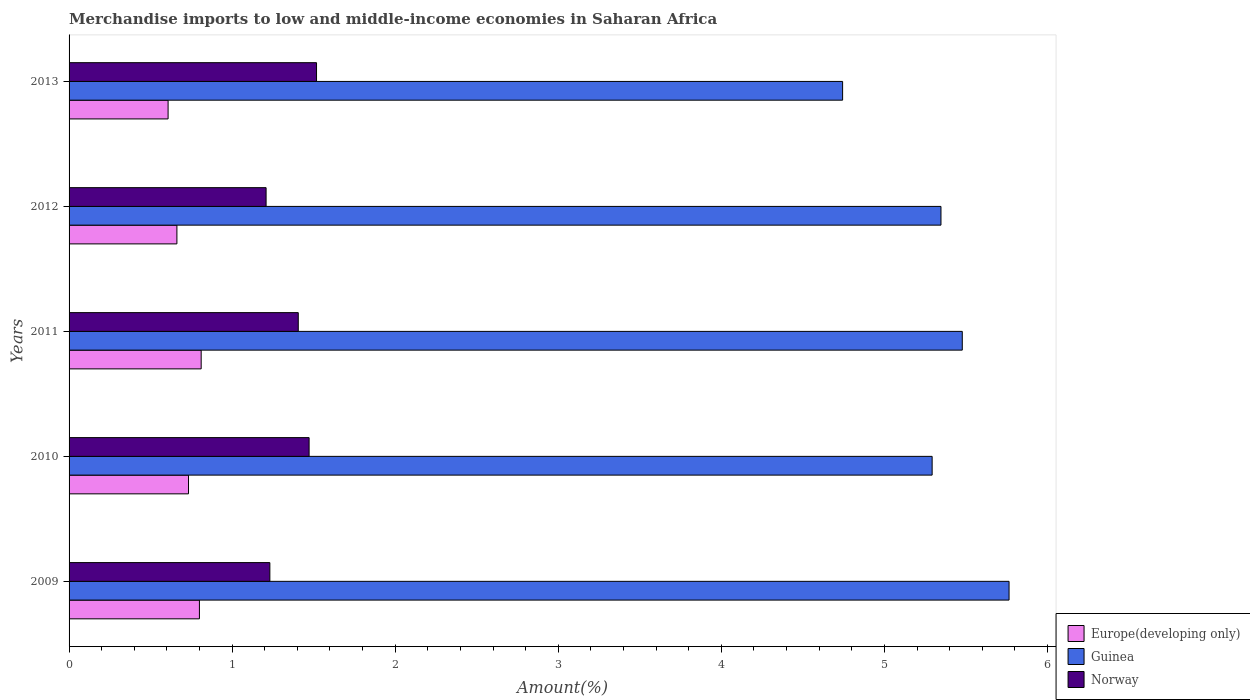How many different coloured bars are there?
Your answer should be compact. 3. Are the number of bars on each tick of the Y-axis equal?
Your response must be concise. Yes. How many bars are there on the 5th tick from the top?
Make the answer very short. 3. How many bars are there on the 2nd tick from the bottom?
Make the answer very short. 3. What is the percentage of amount earned from merchandise imports in Europe(developing only) in 2011?
Ensure brevity in your answer.  0.81. Across all years, what is the maximum percentage of amount earned from merchandise imports in Guinea?
Your answer should be very brief. 5.76. Across all years, what is the minimum percentage of amount earned from merchandise imports in Norway?
Keep it short and to the point. 1.21. In which year was the percentage of amount earned from merchandise imports in Guinea minimum?
Ensure brevity in your answer.  2013. What is the total percentage of amount earned from merchandise imports in Norway in the graph?
Offer a very short reply. 6.83. What is the difference between the percentage of amount earned from merchandise imports in Norway in 2011 and that in 2012?
Your response must be concise. 0.2. What is the difference between the percentage of amount earned from merchandise imports in Guinea in 2010 and the percentage of amount earned from merchandise imports in Europe(developing only) in 2013?
Your response must be concise. 4.69. What is the average percentage of amount earned from merchandise imports in Guinea per year?
Your response must be concise. 5.33. In the year 2011, what is the difference between the percentage of amount earned from merchandise imports in Guinea and percentage of amount earned from merchandise imports in Norway?
Provide a short and direct response. 4.07. What is the ratio of the percentage of amount earned from merchandise imports in Europe(developing only) in 2009 to that in 2011?
Give a very brief answer. 0.99. Is the percentage of amount earned from merchandise imports in Norway in 2010 less than that in 2013?
Provide a succinct answer. Yes. Is the difference between the percentage of amount earned from merchandise imports in Guinea in 2012 and 2013 greater than the difference between the percentage of amount earned from merchandise imports in Norway in 2012 and 2013?
Your answer should be very brief. Yes. What is the difference between the highest and the second highest percentage of amount earned from merchandise imports in Norway?
Give a very brief answer. 0.05. What is the difference between the highest and the lowest percentage of amount earned from merchandise imports in Europe(developing only)?
Keep it short and to the point. 0.2. What does the 2nd bar from the bottom in 2012 represents?
Give a very brief answer. Guinea. Are all the bars in the graph horizontal?
Your answer should be very brief. Yes. Are the values on the major ticks of X-axis written in scientific E-notation?
Your answer should be compact. No. Does the graph contain grids?
Your answer should be very brief. No. How many legend labels are there?
Your answer should be compact. 3. What is the title of the graph?
Provide a short and direct response. Merchandise imports to low and middle-income economies in Saharan Africa. What is the label or title of the X-axis?
Give a very brief answer. Amount(%). What is the Amount(%) in Europe(developing only) in 2009?
Ensure brevity in your answer.  0.8. What is the Amount(%) of Guinea in 2009?
Make the answer very short. 5.76. What is the Amount(%) of Norway in 2009?
Ensure brevity in your answer.  1.23. What is the Amount(%) in Europe(developing only) in 2010?
Make the answer very short. 0.73. What is the Amount(%) of Guinea in 2010?
Your answer should be compact. 5.29. What is the Amount(%) of Norway in 2010?
Make the answer very short. 1.47. What is the Amount(%) in Europe(developing only) in 2011?
Make the answer very short. 0.81. What is the Amount(%) of Guinea in 2011?
Provide a succinct answer. 5.48. What is the Amount(%) of Norway in 2011?
Provide a short and direct response. 1.41. What is the Amount(%) of Europe(developing only) in 2012?
Your answer should be very brief. 0.66. What is the Amount(%) in Guinea in 2012?
Offer a very short reply. 5.35. What is the Amount(%) of Norway in 2012?
Your answer should be compact. 1.21. What is the Amount(%) in Europe(developing only) in 2013?
Provide a short and direct response. 0.61. What is the Amount(%) in Guinea in 2013?
Provide a succinct answer. 4.74. What is the Amount(%) in Norway in 2013?
Provide a short and direct response. 1.52. Across all years, what is the maximum Amount(%) of Europe(developing only)?
Your response must be concise. 0.81. Across all years, what is the maximum Amount(%) in Guinea?
Your response must be concise. 5.76. Across all years, what is the maximum Amount(%) of Norway?
Provide a short and direct response. 1.52. Across all years, what is the minimum Amount(%) of Europe(developing only)?
Make the answer very short. 0.61. Across all years, what is the minimum Amount(%) of Guinea?
Ensure brevity in your answer.  4.74. Across all years, what is the minimum Amount(%) in Norway?
Keep it short and to the point. 1.21. What is the total Amount(%) of Europe(developing only) in the graph?
Offer a very short reply. 3.61. What is the total Amount(%) of Guinea in the graph?
Your answer should be compact. 26.63. What is the total Amount(%) in Norway in the graph?
Offer a very short reply. 6.83. What is the difference between the Amount(%) in Europe(developing only) in 2009 and that in 2010?
Offer a terse response. 0.07. What is the difference between the Amount(%) of Guinea in 2009 and that in 2010?
Provide a short and direct response. 0.47. What is the difference between the Amount(%) in Norway in 2009 and that in 2010?
Your response must be concise. -0.24. What is the difference between the Amount(%) of Europe(developing only) in 2009 and that in 2011?
Provide a short and direct response. -0.01. What is the difference between the Amount(%) in Guinea in 2009 and that in 2011?
Provide a succinct answer. 0.29. What is the difference between the Amount(%) of Norway in 2009 and that in 2011?
Provide a short and direct response. -0.17. What is the difference between the Amount(%) in Europe(developing only) in 2009 and that in 2012?
Your response must be concise. 0.14. What is the difference between the Amount(%) of Guinea in 2009 and that in 2012?
Offer a terse response. 0.42. What is the difference between the Amount(%) in Norway in 2009 and that in 2012?
Your response must be concise. 0.02. What is the difference between the Amount(%) of Europe(developing only) in 2009 and that in 2013?
Offer a terse response. 0.19. What is the difference between the Amount(%) of Guinea in 2009 and that in 2013?
Ensure brevity in your answer.  1.02. What is the difference between the Amount(%) in Norway in 2009 and that in 2013?
Your answer should be compact. -0.29. What is the difference between the Amount(%) in Europe(developing only) in 2010 and that in 2011?
Offer a terse response. -0.08. What is the difference between the Amount(%) in Guinea in 2010 and that in 2011?
Keep it short and to the point. -0.18. What is the difference between the Amount(%) of Norway in 2010 and that in 2011?
Your answer should be very brief. 0.07. What is the difference between the Amount(%) in Europe(developing only) in 2010 and that in 2012?
Your response must be concise. 0.07. What is the difference between the Amount(%) of Guinea in 2010 and that in 2012?
Make the answer very short. -0.05. What is the difference between the Amount(%) of Norway in 2010 and that in 2012?
Provide a succinct answer. 0.26. What is the difference between the Amount(%) of Europe(developing only) in 2010 and that in 2013?
Offer a terse response. 0.13. What is the difference between the Amount(%) in Guinea in 2010 and that in 2013?
Provide a succinct answer. 0.55. What is the difference between the Amount(%) of Norway in 2010 and that in 2013?
Offer a very short reply. -0.05. What is the difference between the Amount(%) of Europe(developing only) in 2011 and that in 2012?
Provide a short and direct response. 0.15. What is the difference between the Amount(%) of Guinea in 2011 and that in 2012?
Your answer should be very brief. 0.13. What is the difference between the Amount(%) in Norway in 2011 and that in 2012?
Ensure brevity in your answer.  0.2. What is the difference between the Amount(%) of Europe(developing only) in 2011 and that in 2013?
Provide a succinct answer. 0.2. What is the difference between the Amount(%) in Guinea in 2011 and that in 2013?
Provide a short and direct response. 0.73. What is the difference between the Amount(%) of Norway in 2011 and that in 2013?
Your answer should be compact. -0.11. What is the difference between the Amount(%) of Europe(developing only) in 2012 and that in 2013?
Ensure brevity in your answer.  0.05. What is the difference between the Amount(%) in Guinea in 2012 and that in 2013?
Offer a terse response. 0.6. What is the difference between the Amount(%) of Norway in 2012 and that in 2013?
Your answer should be compact. -0.31. What is the difference between the Amount(%) in Europe(developing only) in 2009 and the Amount(%) in Guinea in 2010?
Offer a very short reply. -4.49. What is the difference between the Amount(%) in Europe(developing only) in 2009 and the Amount(%) in Norway in 2010?
Provide a short and direct response. -0.67. What is the difference between the Amount(%) in Guinea in 2009 and the Amount(%) in Norway in 2010?
Keep it short and to the point. 4.29. What is the difference between the Amount(%) in Europe(developing only) in 2009 and the Amount(%) in Guinea in 2011?
Keep it short and to the point. -4.68. What is the difference between the Amount(%) of Europe(developing only) in 2009 and the Amount(%) of Norway in 2011?
Keep it short and to the point. -0.61. What is the difference between the Amount(%) in Guinea in 2009 and the Amount(%) in Norway in 2011?
Your answer should be very brief. 4.36. What is the difference between the Amount(%) in Europe(developing only) in 2009 and the Amount(%) in Guinea in 2012?
Keep it short and to the point. -4.55. What is the difference between the Amount(%) in Europe(developing only) in 2009 and the Amount(%) in Norway in 2012?
Provide a succinct answer. -0.41. What is the difference between the Amount(%) in Guinea in 2009 and the Amount(%) in Norway in 2012?
Make the answer very short. 4.56. What is the difference between the Amount(%) in Europe(developing only) in 2009 and the Amount(%) in Guinea in 2013?
Your answer should be very brief. -3.94. What is the difference between the Amount(%) in Europe(developing only) in 2009 and the Amount(%) in Norway in 2013?
Provide a succinct answer. -0.72. What is the difference between the Amount(%) of Guinea in 2009 and the Amount(%) of Norway in 2013?
Ensure brevity in your answer.  4.25. What is the difference between the Amount(%) in Europe(developing only) in 2010 and the Amount(%) in Guinea in 2011?
Your answer should be compact. -4.75. What is the difference between the Amount(%) in Europe(developing only) in 2010 and the Amount(%) in Norway in 2011?
Your response must be concise. -0.67. What is the difference between the Amount(%) of Guinea in 2010 and the Amount(%) of Norway in 2011?
Give a very brief answer. 3.89. What is the difference between the Amount(%) in Europe(developing only) in 2010 and the Amount(%) in Guinea in 2012?
Your response must be concise. -4.61. What is the difference between the Amount(%) in Europe(developing only) in 2010 and the Amount(%) in Norway in 2012?
Offer a terse response. -0.48. What is the difference between the Amount(%) in Guinea in 2010 and the Amount(%) in Norway in 2012?
Give a very brief answer. 4.08. What is the difference between the Amount(%) of Europe(developing only) in 2010 and the Amount(%) of Guinea in 2013?
Offer a terse response. -4.01. What is the difference between the Amount(%) of Europe(developing only) in 2010 and the Amount(%) of Norway in 2013?
Offer a terse response. -0.79. What is the difference between the Amount(%) of Guinea in 2010 and the Amount(%) of Norway in 2013?
Ensure brevity in your answer.  3.78. What is the difference between the Amount(%) in Europe(developing only) in 2011 and the Amount(%) in Guinea in 2012?
Provide a succinct answer. -4.54. What is the difference between the Amount(%) of Europe(developing only) in 2011 and the Amount(%) of Norway in 2012?
Your response must be concise. -0.4. What is the difference between the Amount(%) in Guinea in 2011 and the Amount(%) in Norway in 2012?
Keep it short and to the point. 4.27. What is the difference between the Amount(%) in Europe(developing only) in 2011 and the Amount(%) in Guinea in 2013?
Provide a short and direct response. -3.93. What is the difference between the Amount(%) of Europe(developing only) in 2011 and the Amount(%) of Norway in 2013?
Offer a very short reply. -0.71. What is the difference between the Amount(%) in Guinea in 2011 and the Amount(%) in Norway in 2013?
Keep it short and to the point. 3.96. What is the difference between the Amount(%) in Europe(developing only) in 2012 and the Amount(%) in Guinea in 2013?
Ensure brevity in your answer.  -4.08. What is the difference between the Amount(%) of Europe(developing only) in 2012 and the Amount(%) of Norway in 2013?
Offer a terse response. -0.86. What is the difference between the Amount(%) in Guinea in 2012 and the Amount(%) in Norway in 2013?
Your answer should be very brief. 3.83. What is the average Amount(%) of Europe(developing only) per year?
Offer a very short reply. 0.72. What is the average Amount(%) in Guinea per year?
Your response must be concise. 5.33. What is the average Amount(%) in Norway per year?
Give a very brief answer. 1.37. In the year 2009, what is the difference between the Amount(%) of Europe(developing only) and Amount(%) of Guinea?
Provide a succinct answer. -4.97. In the year 2009, what is the difference between the Amount(%) of Europe(developing only) and Amount(%) of Norway?
Your response must be concise. -0.43. In the year 2009, what is the difference between the Amount(%) in Guinea and Amount(%) in Norway?
Keep it short and to the point. 4.53. In the year 2010, what is the difference between the Amount(%) in Europe(developing only) and Amount(%) in Guinea?
Provide a succinct answer. -4.56. In the year 2010, what is the difference between the Amount(%) in Europe(developing only) and Amount(%) in Norway?
Give a very brief answer. -0.74. In the year 2010, what is the difference between the Amount(%) of Guinea and Amount(%) of Norway?
Provide a succinct answer. 3.82. In the year 2011, what is the difference between the Amount(%) of Europe(developing only) and Amount(%) of Guinea?
Offer a terse response. -4.67. In the year 2011, what is the difference between the Amount(%) in Europe(developing only) and Amount(%) in Norway?
Your response must be concise. -0.6. In the year 2011, what is the difference between the Amount(%) of Guinea and Amount(%) of Norway?
Your answer should be compact. 4.07. In the year 2012, what is the difference between the Amount(%) in Europe(developing only) and Amount(%) in Guinea?
Your answer should be very brief. -4.69. In the year 2012, what is the difference between the Amount(%) in Europe(developing only) and Amount(%) in Norway?
Offer a very short reply. -0.55. In the year 2012, what is the difference between the Amount(%) in Guinea and Amount(%) in Norway?
Provide a short and direct response. 4.14. In the year 2013, what is the difference between the Amount(%) in Europe(developing only) and Amount(%) in Guinea?
Your answer should be very brief. -4.14. In the year 2013, what is the difference between the Amount(%) of Europe(developing only) and Amount(%) of Norway?
Your answer should be very brief. -0.91. In the year 2013, what is the difference between the Amount(%) of Guinea and Amount(%) of Norway?
Provide a short and direct response. 3.23. What is the ratio of the Amount(%) in Europe(developing only) in 2009 to that in 2010?
Offer a very short reply. 1.09. What is the ratio of the Amount(%) of Guinea in 2009 to that in 2010?
Provide a succinct answer. 1.09. What is the ratio of the Amount(%) of Norway in 2009 to that in 2010?
Your answer should be very brief. 0.84. What is the ratio of the Amount(%) of Europe(developing only) in 2009 to that in 2011?
Your answer should be very brief. 0.99. What is the ratio of the Amount(%) of Guinea in 2009 to that in 2011?
Your response must be concise. 1.05. What is the ratio of the Amount(%) in Norway in 2009 to that in 2011?
Keep it short and to the point. 0.88. What is the ratio of the Amount(%) in Europe(developing only) in 2009 to that in 2012?
Provide a short and direct response. 1.21. What is the ratio of the Amount(%) of Guinea in 2009 to that in 2012?
Keep it short and to the point. 1.08. What is the ratio of the Amount(%) of Norway in 2009 to that in 2012?
Offer a terse response. 1.02. What is the ratio of the Amount(%) in Europe(developing only) in 2009 to that in 2013?
Offer a very short reply. 1.32. What is the ratio of the Amount(%) of Guinea in 2009 to that in 2013?
Provide a succinct answer. 1.22. What is the ratio of the Amount(%) of Norway in 2009 to that in 2013?
Your response must be concise. 0.81. What is the ratio of the Amount(%) of Europe(developing only) in 2010 to that in 2011?
Offer a terse response. 0.9. What is the ratio of the Amount(%) of Guinea in 2010 to that in 2011?
Give a very brief answer. 0.97. What is the ratio of the Amount(%) in Norway in 2010 to that in 2011?
Provide a short and direct response. 1.05. What is the ratio of the Amount(%) in Europe(developing only) in 2010 to that in 2012?
Your answer should be compact. 1.11. What is the ratio of the Amount(%) of Guinea in 2010 to that in 2012?
Offer a terse response. 0.99. What is the ratio of the Amount(%) of Norway in 2010 to that in 2012?
Your response must be concise. 1.22. What is the ratio of the Amount(%) in Europe(developing only) in 2010 to that in 2013?
Offer a terse response. 1.21. What is the ratio of the Amount(%) of Guinea in 2010 to that in 2013?
Provide a short and direct response. 1.12. What is the ratio of the Amount(%) of Norway in 2010 to that in 2013?
Offer a very short reply. 0.97. What is the ratio of the Amount(%) of Europe(developing only) in 2011 to that in 2012?
Keep it short and to the point. 1.23. What is the ratio of the Amount(%) of Guinea in 2011 to that in 2012?
Provide a succinct answer. 1.02. What is the ratio of the Amount(%) of Norway in 2011 to that in 2012?
Your response must be concise. 1.16. What is the ratio of the Amount(%) of Europe(developing only) in 2011 to that in 2013?
Offer a terse response. 1.33. What is the ratio of the Amount(%) in Guinea in 2011 to that in 2013?
Offer a very short reply. 1.15. What is the ratio of the Amount(%) of Norway in 2011 to that in 2013?
Offer a very short reply. 0.93. What is the ratio of the Amount(%) of Europe(developing only) in 2012 to that in 2013?
Your response must be concise. 1.09. What is the ratio of the Amount(%) of Guinea in 2012 to that in 2013?
Your answer should be compact. 1.13. What is the ratio of the Amount(%) of Norway in 2012 to that in 2013?
Provide a short and direct response. 0.8. What is the difference between the highest and the second highest Amount(%) of Europe(developing only)?
Keep it short and to the point. 0.01. What is the difference between the highest and the second highest Amount(%) of Guinea?
Provide a succinct answer. 0.29. What is the difference between the highest and the second highest Amount(%) of Norway?
Offer a very short reply. 0.05. What is the difference between the highest and the lowest Amount(%) in Europe(developing only)?
Offer a terse response. 0.2. What is the difference between the highest and the lowest Amount(%) of Guinea?
Provide a short and direct response. 1.02. What is the difference between the highest and the lowest Amount(%) in Norway?
Your answer should be compact. 0.31. 